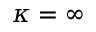Convert formula to latex. <formula><loc_0><loc_0><loc_500><loc_500>\kappa = \infty</formula> 